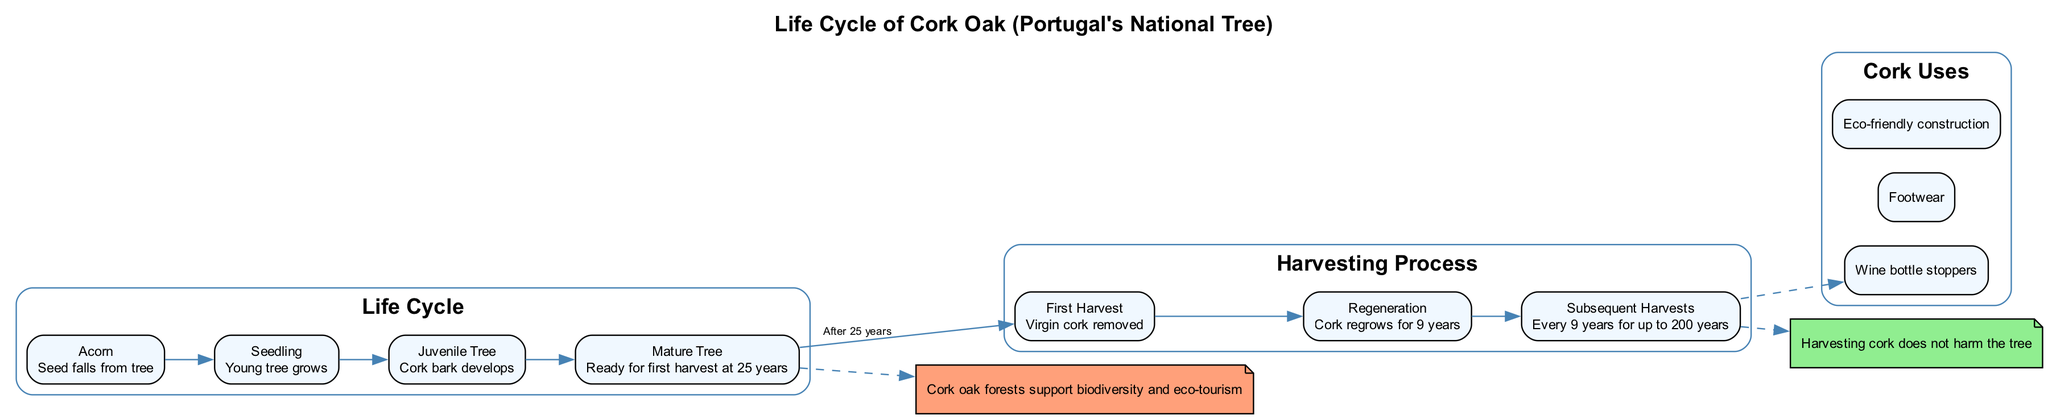What is the first stage of the cork oak life cycle? The diagram lists the stages of the life cycle, starting with the first stage labeled "Acorn," which describes the seed falling from the tree.
Answer: Acorn How many years does it take for a mature cork oak tree to be ready for its first harvest? According to the diagram, the mature tree stage is reached at 25 years, indicating that the tree is ready for its first harvest after that time.
Answer: 25 years What is the description of the "Juvenile Tree" stage? The diagram provides a description for the Juvenile Tree stage, stating that this is when the cork bark develops, elaborating on the growth of the tree.
Answer: Cork bark develops After the first harvest, how long does the cork regrow? The diagram indicates that after the first harvest, the cork regenerates over a period of 9 years before another harvest can take place.
Answer: 9 years Which uses of cork are mentioned in the diagram? The diagram categorizes several cork uses; by examining it, one can find the listed uses such as wine bottle stoppers, footwear, and eco-friendly construction.
Answer: Wine bottle stoppers, Footwear, Eco-friendly construction What indicates that harvesting cork does not harm the tree? The diagram explicitly contains a note stating "Harvesting cork does not harm the tree," serving as a sustainability note and addressing concerns about tree health throughout the harvesting process.
Answer: Harvesting cork does not harm the tree Which node highlights the impact of cork oak forests on tourism? The diagram has a note specifically mentioning the impact of cork oak forests on tourism, detailing how they support biodiversity and eco-tourism.
Answer: Cork oak forests support biodiversity and eco-tourism What is the total number of stages in the cork oak life cycle? By counting the stages outlined in the life cycle portion of the diagram, we find there are four stages: Acorn, Seedling, Juvenile Tree, and Mature Tree.
Answer: 4 What follows the "First Harvest" step in the cork harvesting process? The subsequent step in the harvesting process after "First Harvest" is "Regeneration," which describes the regrowth of cork for nine years following the first removal.
Answer: Regeneration 